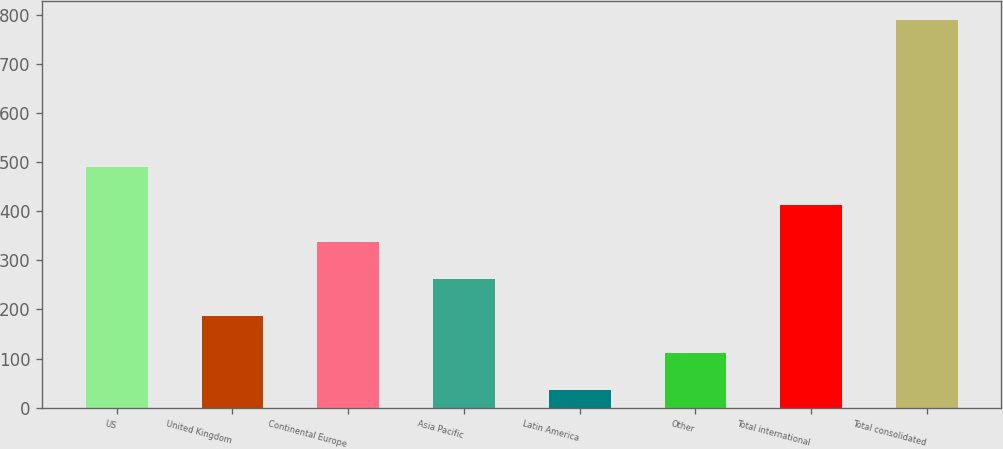<chart> <loc_0><loc_0><loc_500><loc_500><bar_chart><fcel>US<fcel>United Kingdom<fcel>Continental Europe<fcel>Asia Pacific<fcel>Latin America<fcel>Other<fcel>Total international<fcel>Total consolidated<nl><fcel>489.2<fcel>187.26<fcel>337.72<fcel>262.49<fcel>36.8<fcel>112.03<fcel>412.95<fcel>789.1<nl></chart> 